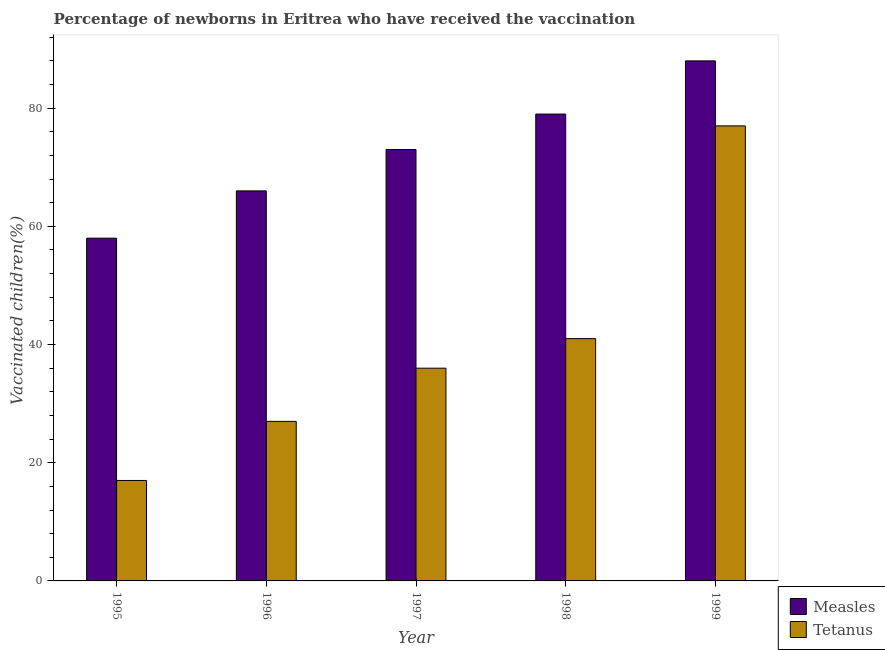Are the number of bars per tick equal to the number of legend labels?
Offer a very short reply. Yes. How many bars are there on the 5th tick from the left?
Give a very brief answer. 2. How many bars are there on the 1st tick from the right?
Your answer should be compact. 2. What is the label of the 3rd group of bars from the left?
Provide a succinct answer. 1997. What is the percentage of newborns who received vaccination for tetanus in 1999?
Your response must be concise. 77. Across all years, what is the maximum percentage of newborns who received vaccination for measles?
Offer a terse response. 88. Across all years, what is the minimum percentage of newborns who received vaccination for tetanus?
Give a very brief answer. 17. In which year was the percentage of newborns who received vaccination for tetanus maximum?
Make the answer very short. 1999. What is the total percentage of newborns who received vaccination for measles in the graph?
Provide a succinct answer. 364. What is the difference between the percentage of newborns who received vaccination for measles in 1998 and that in 1999?
Ensure brevity in your answer.  -9. What is the difference between the percentage of newborns who received vaccination for measles in 1996 and the percentage of newborns who received vaccination for tetanus in 1998?
Ensure brevity in your answer.  -13. What is the average percentage of newborns who received vaccination for tetanus per year?
Give a very brief answer. 39.6. In the year 1995, what is the difference between the percentage of newborns who received vaccination for measles and percentage of newborns who received vaccination for tetanus?
Your response must be concise. 0. What is the ratio of the percentage of newborns who received vaccination for measles in 1997 to that in 1999?
Offer a very short reply. 0.83. Is the percentage of newborns who received vaccination for tetanus in 1996 less than that in 1997?
Your response must be concise. Yes. Is the difference between the percentage of newborns who received vaccination for tetanus in 1995 and 1997 greater than the difference between the percentage of newborns who received vaccination for measles in 1995 and 1997?
Offer a very short reply. No. What is the difference between the highest and the second highest percentage of newborns who received vaccination for measles?
Make the answer very short. 9. What is the difference between the highest and the lowest percentage of newborns who received vaccination for tetanus?
Keep it short and to the point. 60. What does the 2nd bar from the left in 1999 represents?
Your answer should be compact. Tetanus. What does the 1st bar from the right in 1996 represents?
Your answer should be very brief. Tetanus. Are all the bars in the graph horizontal?
Provide a short and direct response. No. What is the difference between two consecutive major ticks on the Y-axis?
Make the answer very short. 20. Where does the legend appear in the graph?
Your answer should be compact. Bottom right. What is the title of the graph?
Offer a terse response. Percentage of newborns in Eritrea who have received the vaccination. What is the label or title of the Y-axis?
Your answer should be very brief. Vaccinated children(%)
. What is the Vaccinated children(%)
 of Tetanus in 1995?
Offer a terse response. 17. What is the Vaccinated children(%)
 in Tetanus in 1996?
Your response must be concise. 27. What is the Vaccinated children(%)
 of Measles in 1998?
Provide a short and direct response. 79. What is the Vaccinated children(%)
 of Tetanus in 1998?
Offer a very short reply. 41. What is the Vaccinated children(%)
 in Measles in 1999?
Give a very brief answer. 88. What is the Vaccinated children(%)
 in Tetanus in 1999?
Your answer should be very brief. 77. Across all years, what is the maximum Vaccinated children(%)
 of Measles?
Give a very brief answer. 88. What is the total Vaccinated children(%)
 of Measles in the graph?
Your answer should be very brief. 364. What is the total Vaccinated children(%)
 of Tetanus in the graph?
Make the answer very short. 198. What is the difference between the Vaccinated children(%)
 of Measles in 1995 and that in 1996?
Offer a terse response. -8. What is the difference between the Vaccinated children(%)
 in Tetanus in 1995 and that in 1996?
Your answer should be very brief. -10. What is the difference between the Vaccinated children(%)
 of Measles in 1995 and that in 1997?
Your answer should be very brief. -15. What is the difference between the Vaccinated children(%)
 of Tetanus in 1995 and that in 1997?
Provide a succinct answer. -19. What is the difference between the Vaccinated children(%)
 in Tetanus in 1995 and that in 1998?
Provide a succinct answer. -24. What is the difference between the Vaccinated children(%)
 of Tetanus in 1995 and that in 1999?
Provide a short and direct response. -60. What is the difference between the Vaccinated children(%)
 of Tetanus in 1996 and that in 1997?
Provide a short and direct response. -9. What is the difference between the Vaccinated children(%)
 of Measles in 1996 and that in 1999?
Offer a terse response. -22. What is the difference between the Vaccinated children(%)
 in Tetanus in 1996 and that in 1999?
Offer a very short reply. -50. What is the difference between the Vaccinated children(%)
 of Measles in 1997 and that in 1998?
Your response must be concise. -6. What is the difference between the Vaccinated children(%)
 in Measles in 1997 and that in 1999?
Offer a very short reply. -15. What is the difference between the Vaccinated children(%)
 in Tetanus in 1997 and that in 1999?
Keep it short and to the point. -41. What is the difference between the Vaccinated children(%)
 in Tetanus in 1998 and that in 1999?
Provide a short and direct response. -36. What is the difference between the Vaccinated children(%)
 of Measles in 1996 and the Vaccinated children(%)
 of Tetanus in 1997?
Ensure brevity in your answer.  30. What is the difference between the Vaccinated children(%)
 of Measles in 1996 and the Vaccinated children(%)
 of Tetanus in 1999?
Provide a short and direct response. -11. What is the difference between the Vaccinated children(%)
 in Measles in 1997 and the Vaccinated children(%)
 in Tetanus in 1998?
Make the answer very short. 32. What is the difference between the Vaccinated children(%)
 in Measles in 1998 and the Vaccinated children(%)
 in Tetanus in 1999?
Your answer should be very brief. 2. What is the average Vaccinated children(%)
 in Measles per year?
Offer a very short reply. 72.8. What is the average Vaccinated children(%)
 of Tetanus per year?
Your answer should be compact. 39.6. In the year 1995, what is the difference between the Vaccinated children(%)
 of Measles and Vaccinated children(%)
 of Tetanus?
Your response must be concise. 41. What is the ratio of the Vaccinated children(%)
 of Measles in 1995 to that in 1996?
Offer a very short reply. 0.88. What is the ratio of the Vaccinated children(%)
 of Tetanus in 1995 to that in 1996?
Provide a succinct answer. 0.63. What is the ratio of the Vaccinated children(%)
 in Measles in 1995 to that in 1997?
Your answer should be compact. 0.79. What is the ratio of the Vaccinated children(%)
 of Tetanus in 1995 to that in 1997?
Make the answer very short. 0.47. What is the ratio of the Vaccinated children(%)
 in Measles in 1995 to that in 1998?
Offer a terse response. 0.73. What is the ratio of the Vaccinated children(%)
 of Tetanus in 1995 to that in 1998?
Offer a terse response. 0.41. What is the ratio of the Vaccinated children(%)
 in Measles in 1995 to that in 1999?
Offer a terse response. 0.66. What is the ratio of the Vaccinated children(%)
 in Tetanus in 1995 to that in 1999?
Give a very brief answer. 0.22. What is the ratio of the Vaccinated children(%)
 in Measles in 1996 to that in 1997?
Provide a succinct answer. 0.9. What is the ratio of the Vaccinated children(%)
 in Measles in 1996 to that in 1998?
Make the answer very short. 0.84. What is the ratio of the Vaccinated children(%)
 of Tetanus in 1996 to that in 1998?
Ensure brevity in your answer.  0.66. What is the ratio of the Vaccinated children(%)
 in Measles in 1996 to that in 1999?
Keep it short and to the point. 0.75. What is the ratio of the Vaccinated children(%)
 of Tetanus in 1996 to that in 1999?
Your answer should be compact. 0.35. What is the ratio of the Vaccinated children(%)
 of Measles in 1997 to that in 1998?
Provide a short and direct response. 0.92. What is the ratio of the Vaccinated children(%)
 in Tetanus in 1997 to that in 1998?
Offer a very short reply. 0.88. What is the ratio of the Vaccinated children(%)
 in Measles in 1997 to that in 1999?
Ensure brevity in your answer.  0.83. What is the ratio of the Vaccinated children(%)
 in Tetanus in 1997 to that in 1999?
Your answer should be compact. 0.47. What is the ratio of the Vaccinated children(%)
 in Measles in 1998 to that in 1999?
Give a very brief answer. 0.9. What is the ratio of the Vaccinated children(%)
 in Tetanus in 1998 to that in 1999?
Offer a terse response. 0.53. What is the difference between the highest and the second highest Vaccinated children(%)
 of Measles?
Make the answer very short. 9. What is the difference between the highest and the second highest Vaccinated children(%)
 of Tetanus?
Offer a very short reply. 36. What is the difference between the highest and the lowest Vaccinated children(%)
 in Measles?
Your answer should be compact. 30. What is the difference between the highest and the lowest Vaccinated children(%)
 of Tetanus?
Your answer should be compact. 60. 